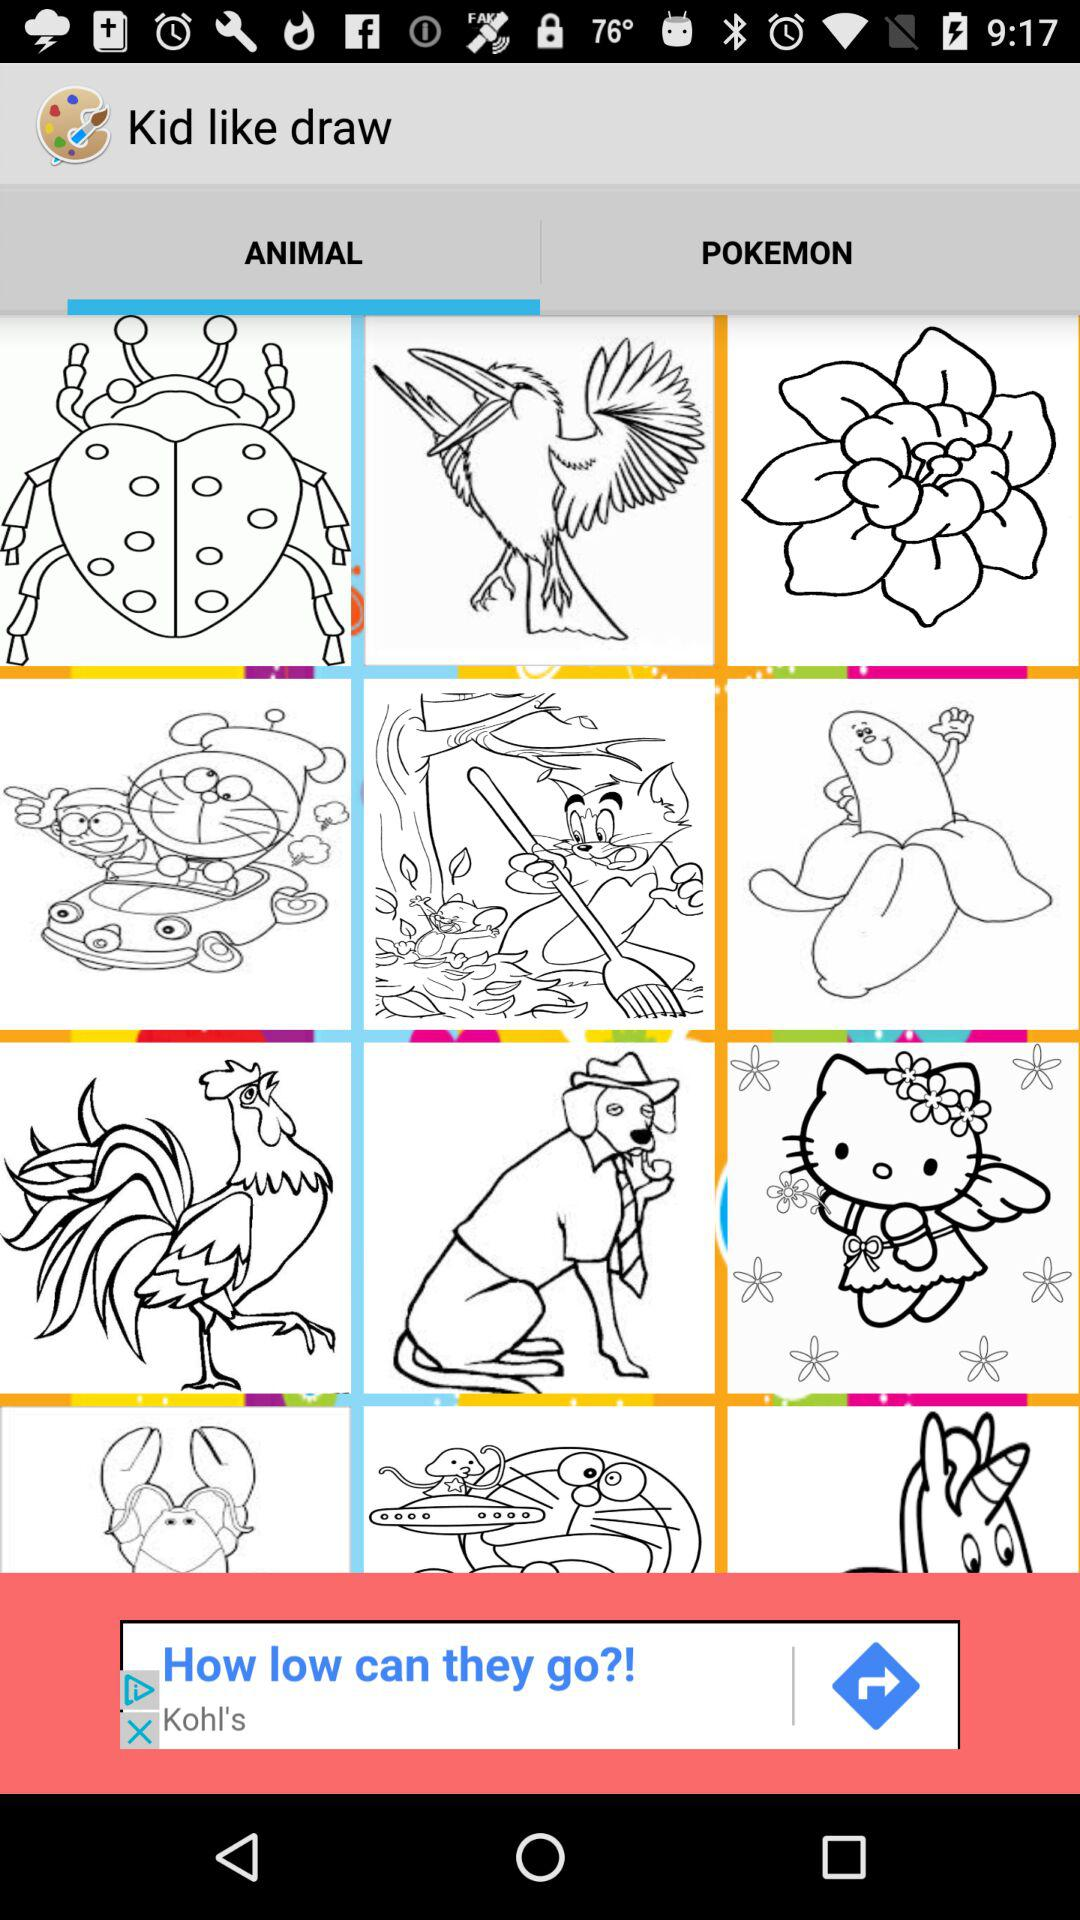Which tab is selected? The selected tab is "ANIMAL". 